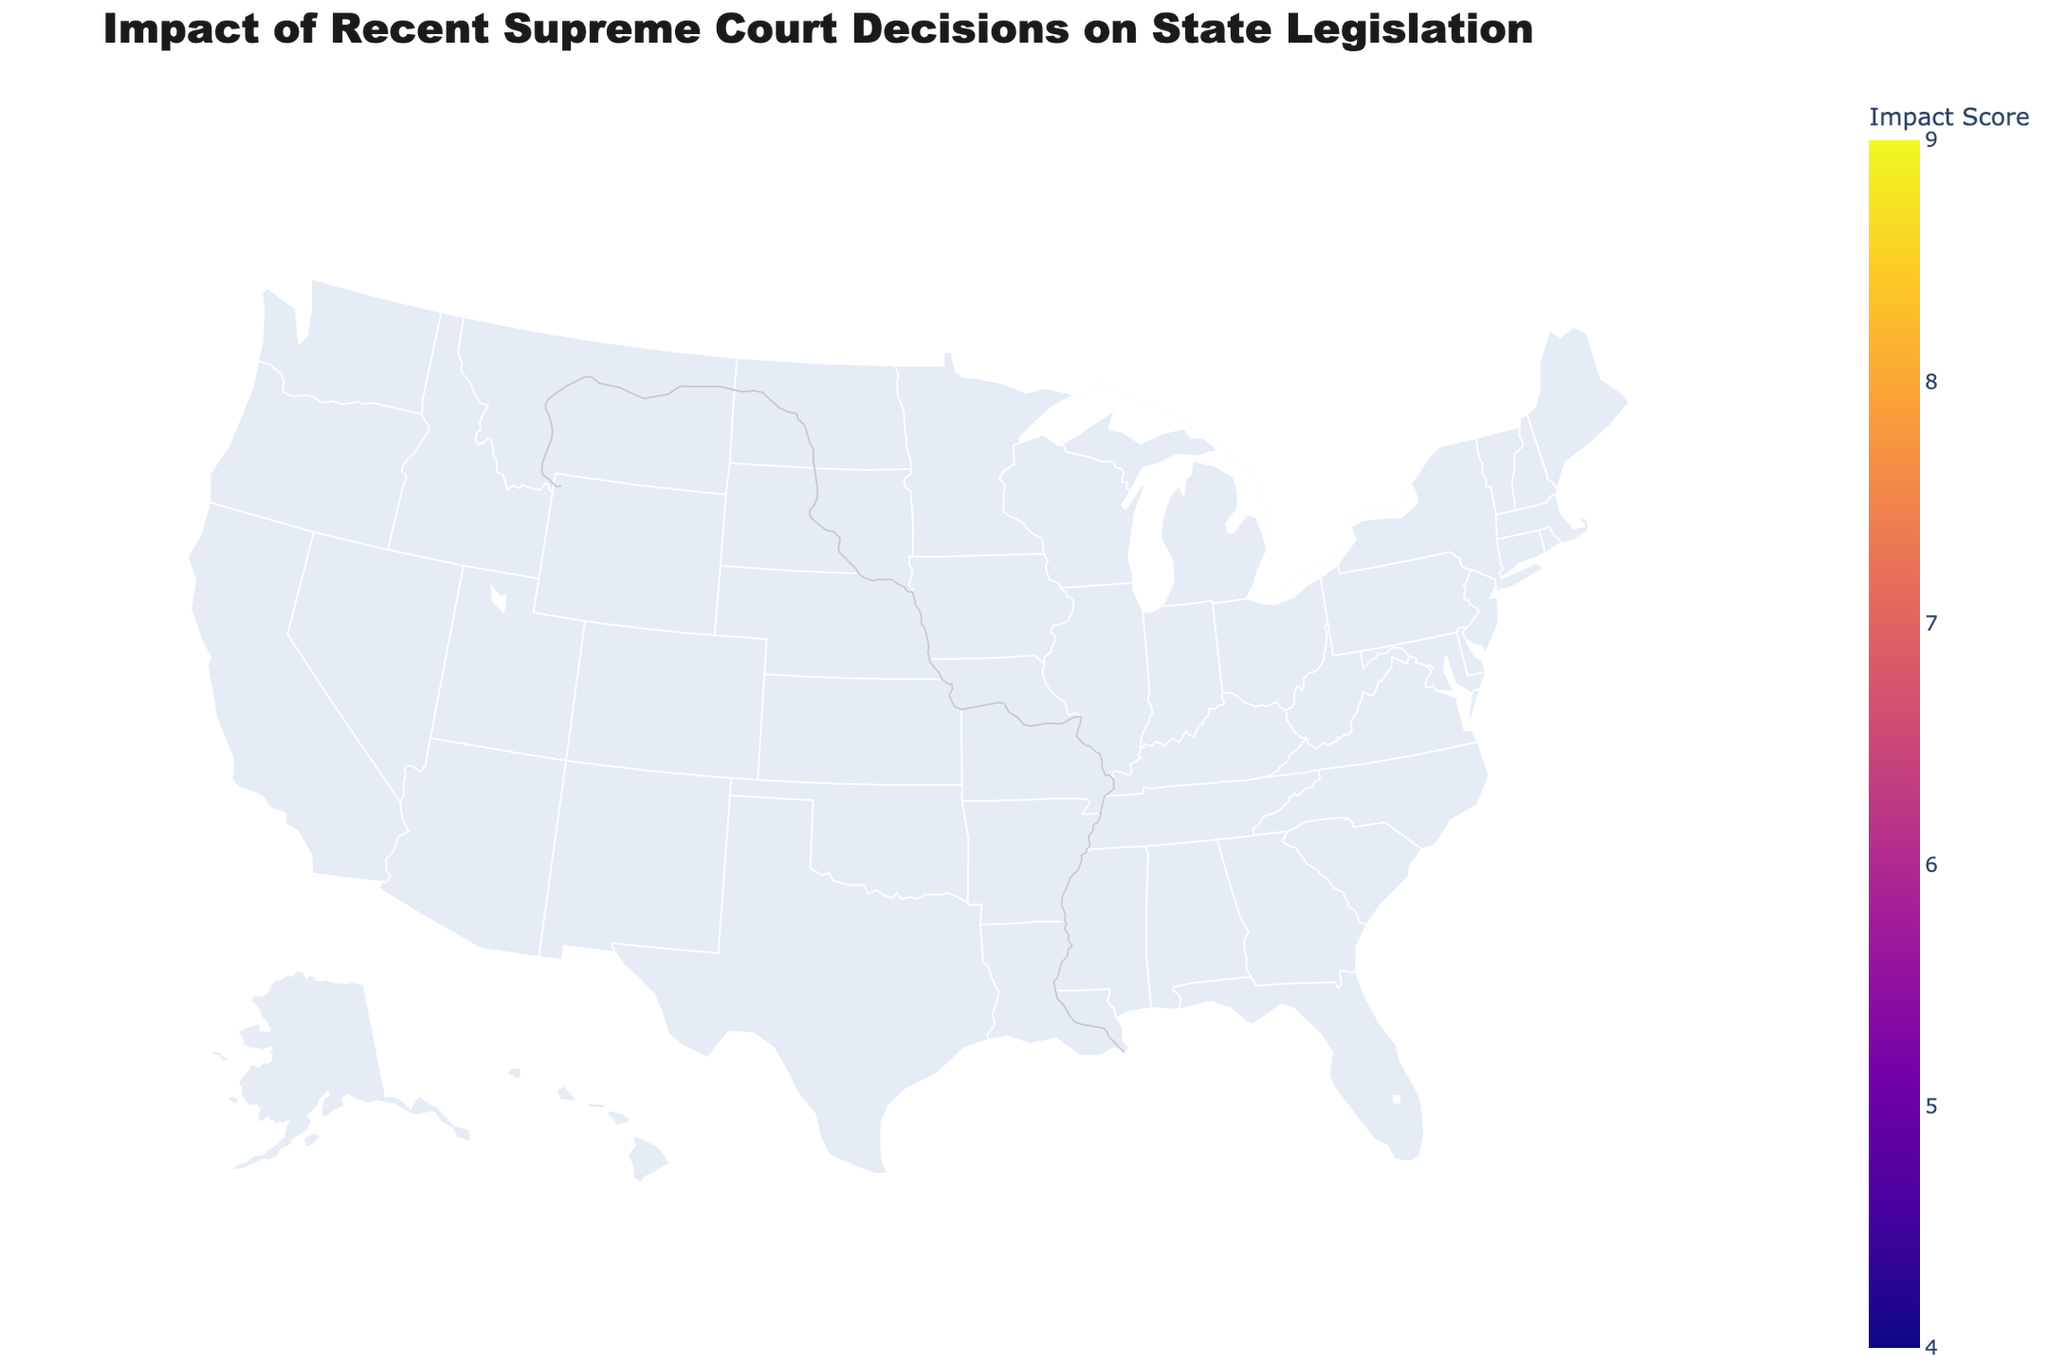What is the title of the plot? The title of the plot is usually displayed prominently at the top. It provides an overview of what the plot represents. In this case, the title is "Impact of Recent Supreme Court Decisions on State Legislation."
Answer: Impact of Recent Supreme Court Decisions on State Legislation Which state has the highest impact score? To find the state with the highest impact score, look for the darkest shade on the color scale. Here, Mississippi, California, and New York all have the highest score of 9.
Answer: Mississippi, California, New York What is the impact score for Texas, and which major decision affected it? Locate Texas on the map and check its color intensity. The hover text or annotations provide details. Texas has an impact score of 8, and it was affected by Dobbs v. Jackson Women's Health Organization.
Answer: 8, Dobbs v. Jackson Women's Health Organization Compare the impact scores between Georgia and Colorado. Which state has a higher score? Identify Georgia and Colorado on the map. Georgia has an impact score of 7, and Colorado has a score of 6. Therefore, Georgia has a higher impact score than Colorado.
Answer: Georgia What is the average impact score of all the states? Sum all the impact scores and divide by the number of states. (8 + 5 + 7 + 9 + 6 + 8 + 7 + 4 + 6 + 7 + 7 + 8 + 6 + 9 + 5 + 9 + 7 + 6 + 8 + 7) = 148. There are 20 states in total. So, the average impact score is 148 / 20 = 7.4
Answer: 7.4 Which major decision appears to have the most widespread impact across different states? Check the hover text or color coding to see which major decision affects the most states. Dobbs v. Jackson Women's Health Organization appears in Alabama, Florida, Idaho, Mississippi, and Texas, affecting the most states.
Answer: Dobbs v. Jackson Women's Health Organization What is the impact score of the least affected state and which major decision impacted it? Look for the lightest shade on the map and check its annotation or hover text. Hawaii has the lowest impact score of 4, affected by West Virginia v. EPA.
Answer: 4, West Virginia v. EPA How many states have an impact score of 7? Identify states with the specific color corresponding to an impact score of 7. There are 6 states: Arizona, Illinois, Georgia, Kentucky, Ohio, and Washington.
Answer: 6 Is there a geographic region (e.g., Southeast, Northwest) that seems to be more impacted by Supreme Court decisions? Analyze the color intensity across different regions. The Southeast (e.g., Alabama, Georgia, Florida,) appears to have high impact scores, suggesting more impact.
Answer: Southeast Compare the impact scores of New York and Montana. Which one is higher and by how much? Locate New York and Montana and check their impact scores. New York has an impact score of 9, and Montana has a score of 5. The difference is 9 - 5 = 4.
Answer: New York, by 4 